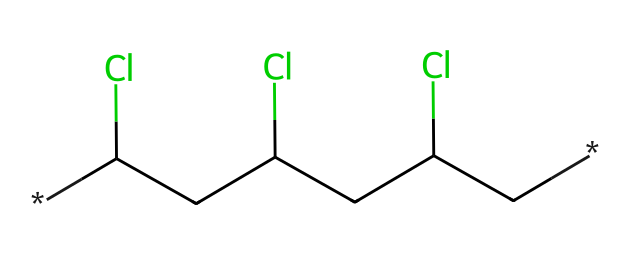What is the main element in the backbone of this polymer? The chemical structure is based on carbon atoms, as indicated by the carbon (C) symbols in the SMILES representation.
Answer: carbon How many chlorine atoms are present in this chemical structure? The chlorine (Cl) atoms can be counted in the SMILES representation, where three Cl symbols indicate their presence.
Answer: three What type of bonds connect the carbon atoms in this polymer? The structure indicates that carbon atoms are connected by single bonds, as there are no double or triple bond symbols present in the SMILES representation.
Answer: single bonds What type of polymer is represented by this chemical structure? The presence of vinyl groups (indicated by the carbon backbone and chlorine functional groups) signifies that this is a vinyl polymer, specifically polyvinyl chloride or PVC.
Answer: vinyl polymer How does the presence of chlorine affect the properties of this polymer? Chlorine increases the rigidity and thermal stability of the polymer, which is essential in applications for vinyl records.
Answer: increases rigidity What is a common use of polyvinyl chloride? PVC is widely used in construction materials, as well as in making vinyl records, due to its durability and versatility.
Answer: construction materials 